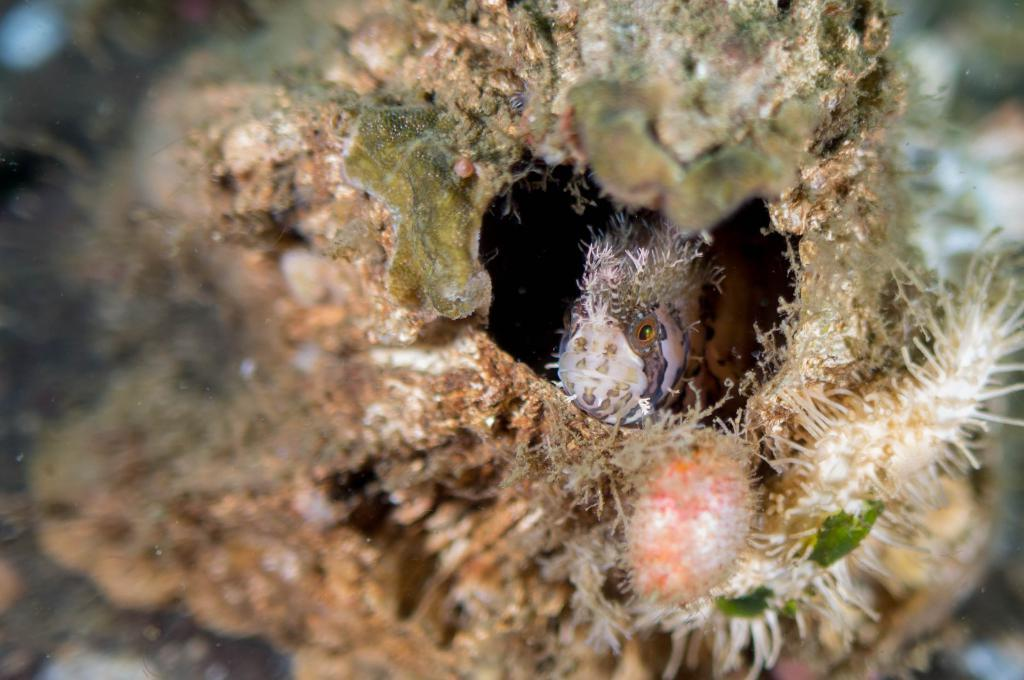What is inside the rock in the image? There is a fish inside the rock in the image. What else can be seen in the image besides the fish? There are aquatic plants in the image. Can you describe the background of the image? The background of the image is blurred. What time of day is it in the image, given the sound of bells ringing? There is no mention of bells ringing or any specific time of day in the image. 